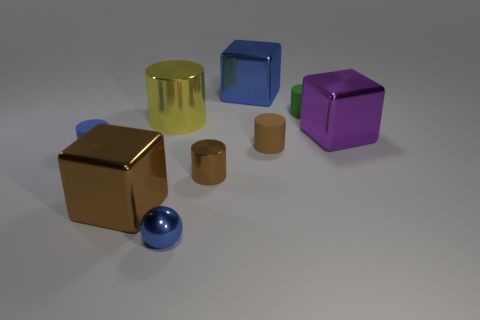Subtract all large yellow cylinders. How many cylinders are left? 4 Subtract all cylinders. How many objects are left? 4 Add 1 green cylinders. How many objects exist? 10 Add 1 blue shiny spheres. How many blue shiny spheres are left? 2 Add 7 brown rubber objects. How many brown rubber objects exist? 8 Subtract all brown cylinders. How many cylinders are left? 3 Subtract 1 brown cylinders. How many objects are left? 8 Subtract 1 spheres. How many spheres are left? 0 Subtract all red balls. Subtract all purple cubes. How many balls are left? 1 Subtract all yellow spheres. How many yellow cubes are left? 0 